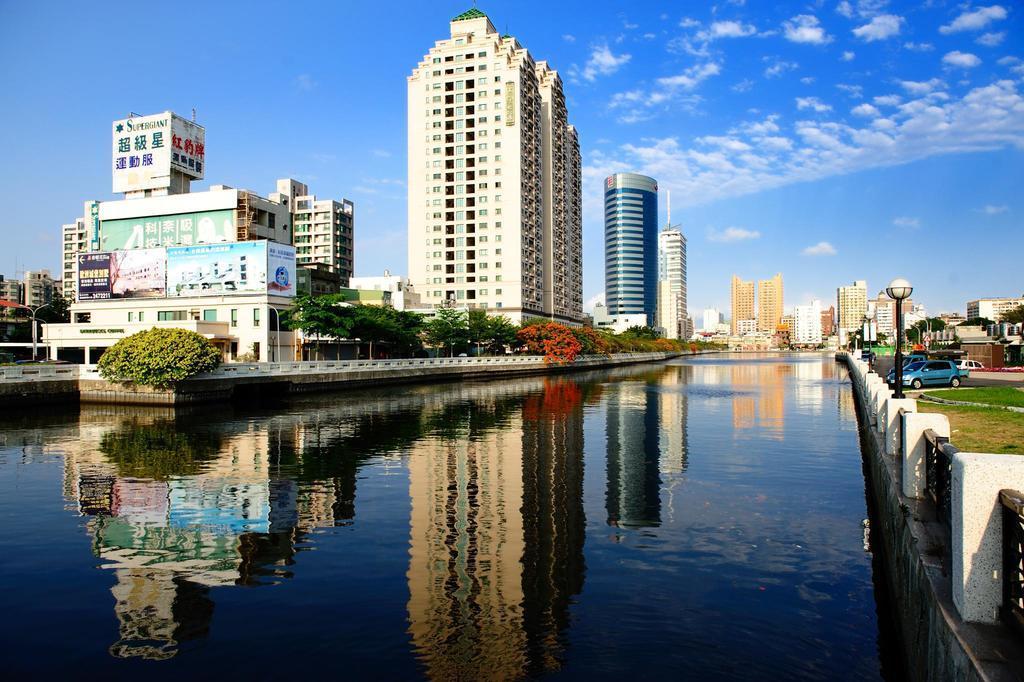Describe this image in one or two sentences. In this picture there are some building and small water pond in the front side. On the right side we can see some cars are parked on the road side. 